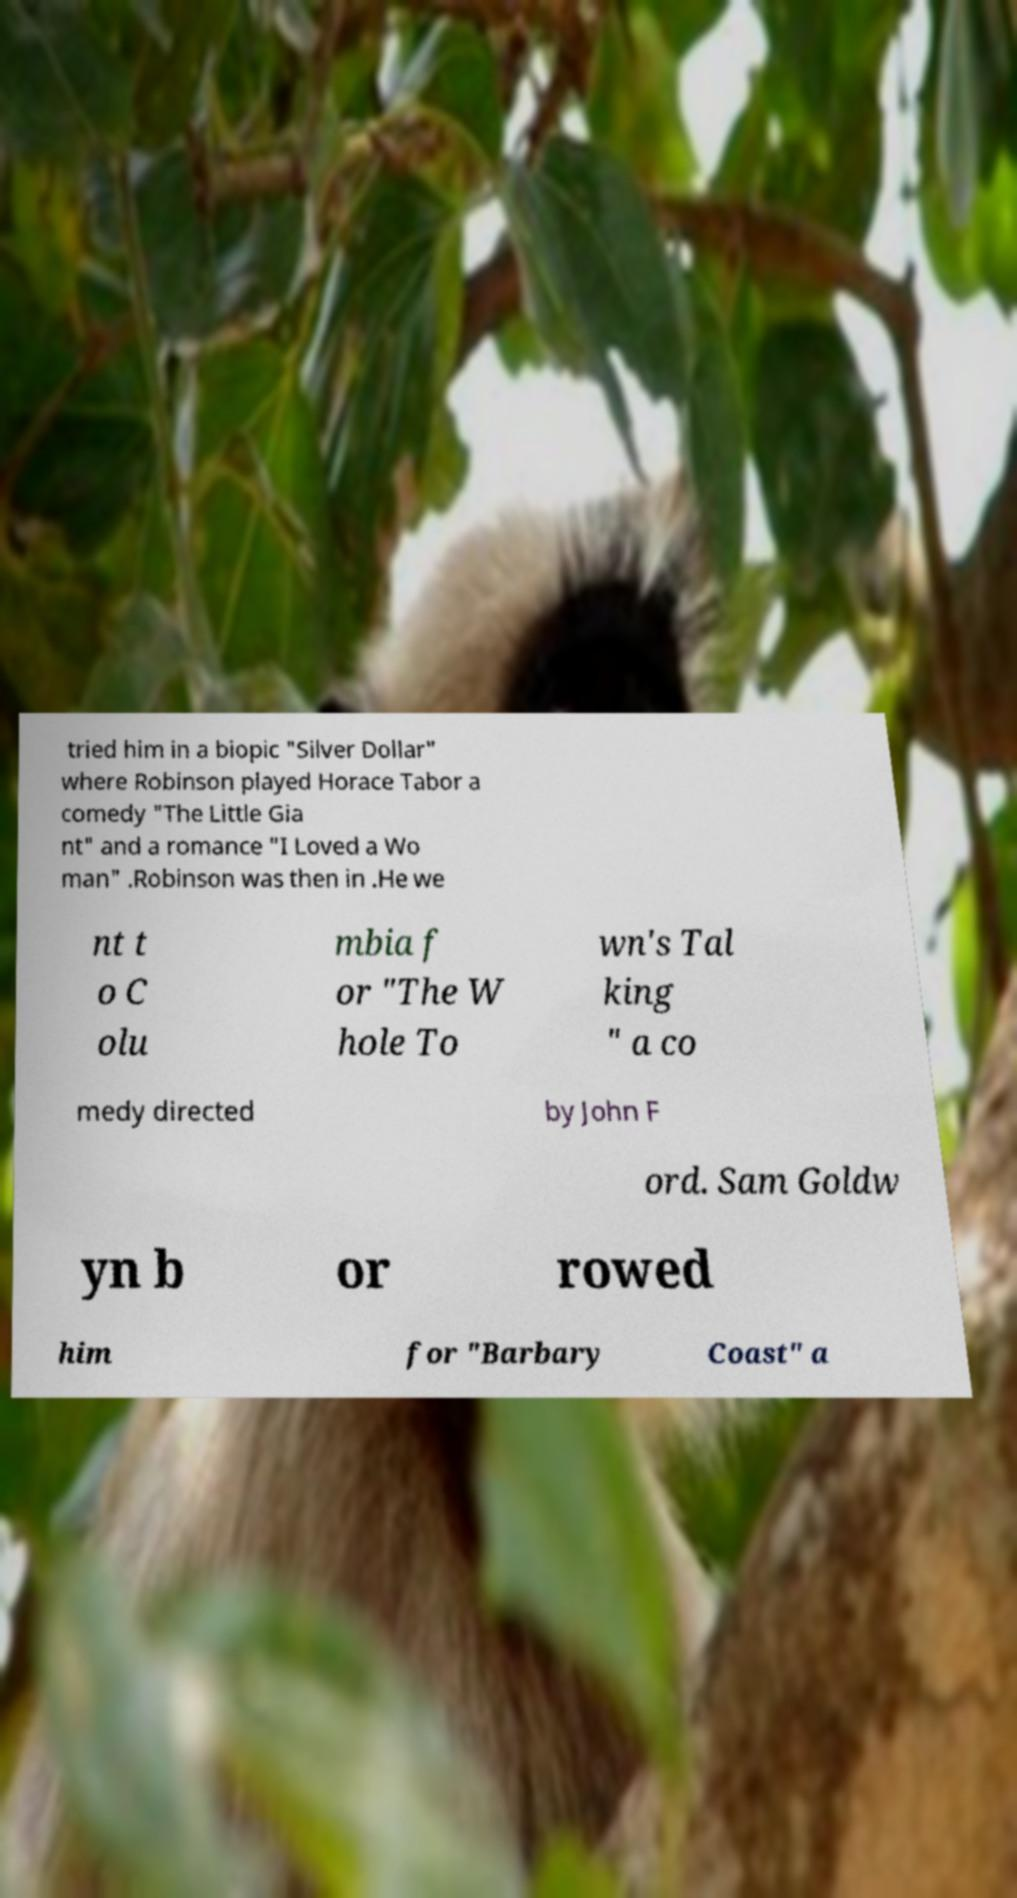There's text embedded in this image that I need extracted. Can you transcribe it verbatim? tried him in a biopic "Silver Dollar" where Robinson played Horace Tabor a comedy "The Little Gia nt" and a romance "I Loved a Wo man" .Robinson was then in .He we nt t o C olu mbia f or "The W hole To wn's Tal king " a co medy directed by John F ord. Sam Goldw yn b or rowed him for "Barbary Coast" a 